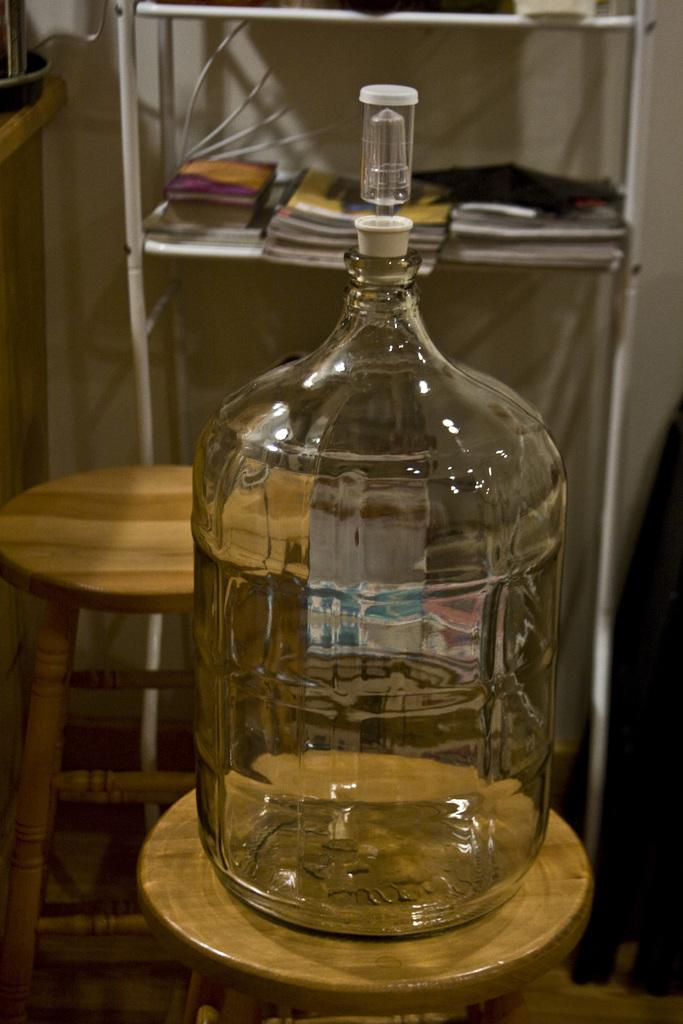What object is in the image that has a nozzle? There is a glass jar in the image that has a nozzle in its mouth. Where is the glass jar placed? The glass jar is placed on a stool. In what type of setting does the scene take place? The scene takes place in a room. What type of plants can be seen growing on the body in the image? There are no plants or bodies present in the image; it only features a glass jar with a nozzle placed on a stool in a room. 